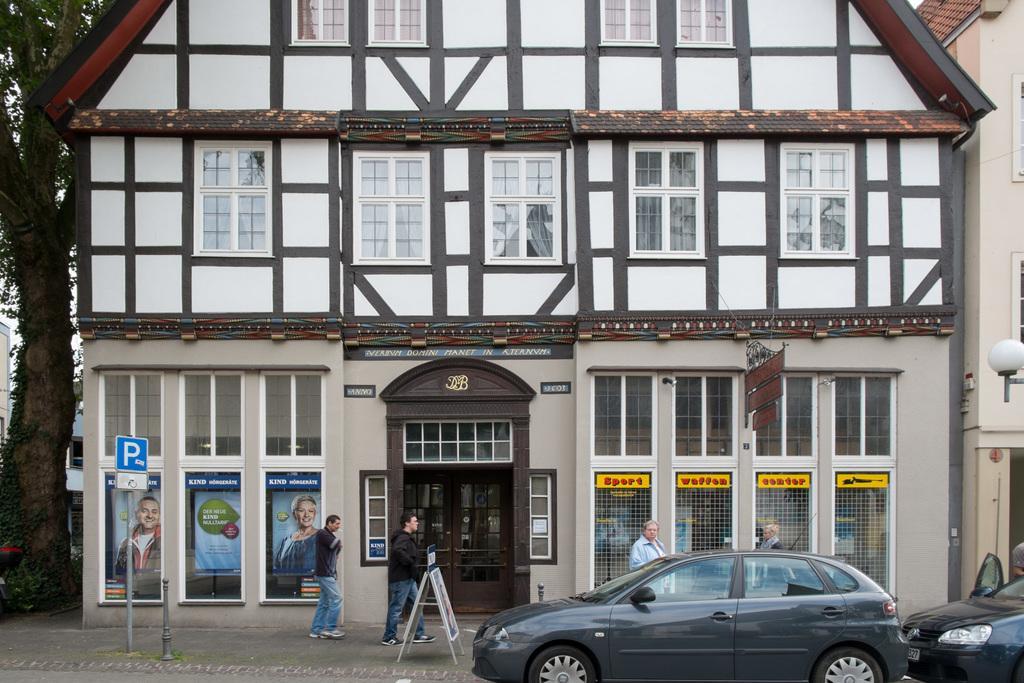Can you describe this image briefly? In the foreground we can see people cars, people, board, poles and footpath. In the middle of the of the picture there are buildings. On the left we can see trees and buildings. 